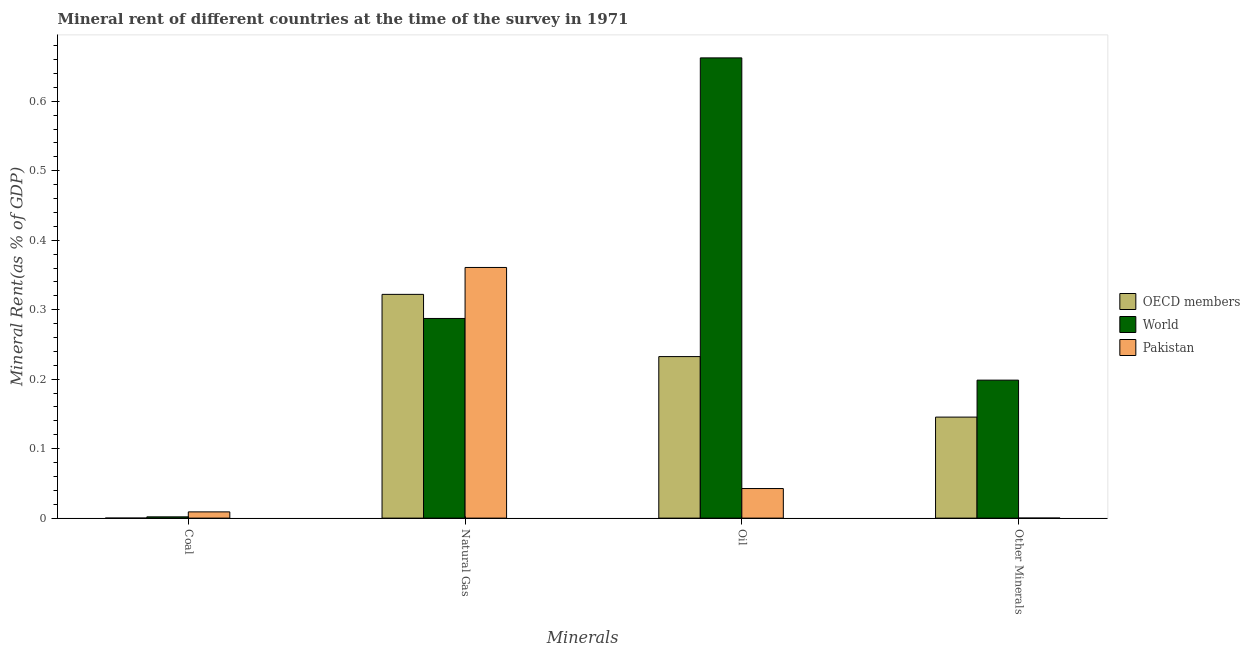How many different coloured bars are there?
Offer a terse response. 3. How many groups of bars are there?
Your response must be concise. 4. Are the number of bars on each tick of the X-axis equal?
Provide a short and direct response. Yes. How many bars are there on the 3rd tick from the left?
Make the answer very short. 3. How many bars are there on the 2nd tick from the right?
Offer a very short reply. 3. What is the label of the 4th group of bars from the left?
Make the answer very short. Other Minerals. What is the natural gas rent in OECD members?
Make the answer very short. 0.32. Across all countries, what is the maximum  rent of other minerals?
Your answer should be very brief. 0.2. Across all countries, what is the minimum  rent of other minerals?
Give a very brief answer. 2.58008287819044e-5. In which country was the oil rent maximum?
Make the answer very short. World. What is the total  rent of other minerals in the graph?
Your answer should be very brief. 0.34. What is the difference between the oil rent in World and that in Pakistan?
Your answer should be very brief. 0.62. What is the difference between the oil rent in World and the coal rent in OECD members?
Your response must be concise. 0.66. What is the average  rent of other minerals per country?
Offer a very short reply. 0.11. What is the difference between the coal rent and  rent of other minerals in World?
Your answer should be very brief. -0.2. In how many countries, is the oil rent greater than 0.32000000000000006 %?
Your answer should be very brief. 1. What is the ratio of the  rent of other minerals in World to that in OECD members?
Make the answer very short. 1.37. Is the natural gas rent in OECD members less than that in World?
Your response must be concise. No. Is the difference between the  rent of other minerals in World and Pakistan greater than the difference between the natural gas rent in World and Pakistan?
Give a very brief answer. Yes. What is the difference between the highest and the second highest  rent of other minerals?
Give a very brief answer. 0.05. What is the difference between the highest and the lowest coal rent?
Make the answer very short. 0.01. In how many countries, is the coal rent greater than the average coal rent taken over all countries?
Provide a succinct answer. 1. Is it the case that in every country, the sum of the oil rent and natural gas rent is greater than the sum of  rent of other minerals and coal rent?
Your answer should be compact. No. What does the 3rd bar from the right in Coal represents?
Your response must be concise. OECD members. Is it the case that in every country, the sum of the coal rent and natural gas rent is greater than the oil rent?
Offer a terse response. No. Are all the bars in the graph horizontal?
Keep it short and to the point. No. What is the difference between two consecutive major ticks on the Y-axis?
Your answer should be compact. 0.1. Does the graph contain grids?
Offer a very short reply. No. Where does the legend appear in the graph?
Provide a short and direct response. Center right. How many legend labels are there?
Keep it short and to the point. 3. What is the title of the graph?
Ensure brevity in your answer.  Mineral rent of different countries at the time of the survey in 1971. Does "Burkina Faso" appear as one of the legend labels in the graph?
Give a very brief answer. No. What is the label or title of the X-axis?
Keep it short and to the point. Minerals. What is the label or title of the Y-axis?
Offer a very short reply. Mineral Rent(as % of GDP). What is the Mineral Rent(as % of GDP) in OECD members in Coal?
Your response must be concise. 1.83188177110096e-6. What is the Mineral Rent(as % of GDP) of World in Coal?
Your answer should be very brief. 0. What is the Mineral Rent(as % of GDP) of Pakistan in Coal?
Ensure brevity in your answer.  0.01. What is the Mineral Rent(as % of GDP) of OECD members in Natural Gas?
Your answer should be compact. 0.32. What is the Mineral Rent(as % of GDP) of World in Natural Gas?
Provide a short and direct response. 0.29. What is the Mineral Rent(as % of GDP) in Pakistan in Natural Gas?
Offer a very short reply. 0.36. What is the Mineral Rent(as % of GDP) in OECD members in Oil?
Keep it short and to the point. 0.23. What is the Mineral Rent(as % of GDP) in World in Oil?
Offer a terse response. 0.66. What is the Mineral Rent(as % of GDP) in Pakistan in Oil?
Ensure brevity in your answer.  0.04. What is the Mineral Rent(as % of GDP) of OECD members in Other Minerals?
Make the answer very short. 0.15. What is the Mineral Rent(as % of GDP) of World in Other Minerals?
Your answer should be very brief. 0.2. What is the Mineral Rent(as % of GDP) of Pakistan in Other Minerals?
Your answer should be very brief. 2.58008287819044e-5. Across all Minerals, what is the maximum Mineral Rent(as % of GDP) in OECD members?
Offer a very short reply. 0.32. Across all Minerals, what is the maximum Mineral Rent(as % of GDP) of World?
Ensure brevity in your answer.  0.66. Across all Minerals, what is the maximum Mineral Rent(as % of GDP) of Pakistan?
Provide a short and direct response. 0.36. Across all Minerals, what is the minimum Mineral Rent(as % of GDP) of OECD members?
Offer a terse response. 1.83188177110096e-6. Across all Minerals, what is the minimum Mineral Rent(as % of GDP) of World?
Your response must be concise. 0. Across all Minerals, what is the minimum Mineral Rent(as % of GDP) of Pakistan?
Your answer should be very brief. 2.58008287819044e-5. What is the total Mineral Rent(as % of GDP) of OECD members in the graph?
Your response must be concise. 0.7. What is the total Mineral Rent(as % of GDP) in World in the graph?
Make the answer very short. 1.15. What is the total Mineral Rent(as % of GDP) in Pakistan in the graph?
Offer a very short reply. 0.41. What is the difference between the Mineral Rent(as % of GDP) of OECD members in Coal and that in Natural Gas?
Provide a short and direct response. -0.32. What is the difference between the Mineral Rent(as % of GDP) of World in Coal and that in Natural Gas?
Ensure brevity in your answer.  -0.29. What is the difference between the Mineral Rent(as % of GDP) of Pakistan in Coal and that in Natural Gas?
Provide a succinct answer. -0.35. What is the difference between the Mineral Rent(as % of GDP) in OECD members in Coal and that in Oil?
Your answer should be very brief. -0.23. What is the difference between the Mineral Rent(as % of GDP) of World in Coal and that in Oil?
Your response must be concise. -0.66. What is the difference between the Mineral Rent(as % of GDP) in Pakistan in Coal and that in Oil?
Offer a very short reply. -0.03. What is the difference between the Mineral Rent(as % of GDP) of OECD members in Coal and that in Other Minerals?
Provide a short and direct response. -0.15. What is the difference between the Mineral Rent(as % of GDP) in World in Coal and that in Other Minerals?
Provide a short and direct response. -0.2. What is the difference between the Mineral Rent(as % of GDP) in Pakistan in Coal and that in Other Minerals?
Ensure brevity in your answer.  0.01. What is the difference between the Mineral Rent(as % of GDP) of OECD members in Natural Gas and that in Oil?
Your answer should be compact. 0.09. What is the difference between the Mineral Rent(as % of GDP) in World in Natural Gas and that in Oil?
Ensure brevity in your answer.  -0.38. What is the difference between the Mineral Rent(as % of GDP) of Pakistan in Natural Gas and that in Oil?
Ensure brevity in your answer.  0.32. What is the difference between the Mineral Rent(as % of GDP) in OECD members in Natural Gas and that in Other Minerals?
Give a very brief answer. 0.18. What is the difference between the Mineral Rent(as % of GDP) in World in Natural Gas and that in Other Minerals?
Provide a short and direct response. 0.09. What is the difference between the Mineral Rent(as % of GDP) in Pakistan in Natural Gas and that in Other Minerals?
Make the answer very short. 0.36. What is the difference between the Mineral Rent(as % of GDP) of OECD members in Oil and that in Other Minerals?
Your answer should be compact. 0.09. What is the difference between the Mineral Rent(as % of GDP) of World in Oil and that in Other Minerals?
Your response must be concise. 0.46. What is the difference between the Mineral Rent(as % of GDP) in Pakistan in Oil and that in Other Minerals?
Offer a terse response. 0.04. What is the difference between the Mineral Rent(as % of GDP) in OECD members in Coal and the Mineral Rent(as % of GDP) in World in Natural Gas?
Provide a succinct answer. -0.29. What is the difference between the Mineral Rent(as % of GDP) in OECD members in Coal and the Mineral Rent(as % of GDP) in Pakistan in Natural Gas?
Offer a very short reply. -0.36. What is the difference between the Mineral Rent(as % of GDP) in World in Coal and the Mineral Rent(as % of GDP) in Pakistan in Natural Gas?
Provide a short and direct response. -0.36. What is the difference between the Mineral Rent(as % of GDP) in OECD members in Coal and the Mineral Rent(as % of GDP) in World in Oil?
Offer a very short reply. -0.66. What is the difference between the Mineral Rent(as % of GDP) in OECD members in Coal and the Mineral Rent(as % of GDP) in Pakistan in Oil?
Offer a terse response. -0.04. What is the difference between the Mineral Rent(as % of GDP) in World in Coal and the Mineral Rent(as % of GDP) in Pakistan in Oil?
Provide a succinct answer. -0.04. What is the difference between the Mineral Rent(as % of GDP) of OECD members in Coal and the Mineral Rent(as % of GDP) of World in Other Minerals?
Provide a short and direct response. -0.2. What is the difference between the Mineral Rent(as % of GDP) of World in Coal and the Mineral Rent(as % of GDP) of Pakistan in Other Minerals?
Give a very brief answer. 0. What is the difference between the Mineral Rent(as % of GDP) of OECD members in Natural Gas and the Mineral Rent(as % of GDP) of World in Oil?
Offer a terse response. -0.34. What is the difference between the Mineral Rent(as % of GDP) in OECD members in Natural Gas and the Mineral Rent(as % of GDP) in Pakistan in Oil?
Your answer should be very brief. 0.28. What is the difference between the Mineral Rent(as % of GDP) of World in Natural Gas and the Mineral Rent(as % of GDP) of Pakistan in Oil?
Keep it short and to the point. 0.24. What is the difference between the Mineral Rent(as % of GDP) in OECD members in Natural Gas and the Mineral Rent(as % of GDP) in World in Other Minerals?
Your response must be concise. 0.12. What is the difference between the Mineral Rent(as % of GDP) in OECD members in Natural Gas and the Mineral Rent(as % of GDP) in Pakistan in Other Minerals?
Keep it short and to the point. 0.32. What is the difference between the Mineral Rent(as % of GDP) in World in Natural Gas and the Mineral Rent(as % of GDP) in Pakistan in Other Minerals?
Provide a short and direct response. 0.29. What is the difference between the Mineral Rent(as % of GDP) of OECD members in Oil and the Mineral Rent(as % of GDP) of World in Other Minerals?
Keep it short and to the point. 0.03. What is the difference between the Mineral Rent(as % of GDP) in OECD members in Oil and the Mineral Rent(as % of GDP) in Pakistan in Other Minerals?
Provide a short and direct response. 0.23. What is the difference between the Mineral Rent(as % of GDP) of World in Oil and the Mineral Rent(as % of GDP) of Pakistan in Other Minerals?
Your answer should be compact. 0.66. What is the average Mineral Rent(as % of GDP) in OECD members per Minerals?
Provide a succinct answer. 0.17. What is the average Mineral Rent(as % of GDP) in World per Minerals?
Your response must be concise. 0.29. What is the average Mineral Rent(as % of GDP) of Pakistan per Minerals?
Offer a very short reply. 0.1. What is the difference between the Mineral Rent(as % of GDP) of OECD members and Mineral Rent(as % of GDP) of World in Coal?
Provide a succinct answer. -0. What is the difference between the Mineral Rent(as % of GDP) in OECD members and Mineral Rent(as % of GDP) in Pakistan in Coal?
Make the answer very short. -0.01. What is the difference between the Mineral Rent(as % of GDP) of World and Mineral Rent(as % of GDP) of Pakistan in Coal?
Ensure brevity in your answer.  -0.01. What is the difference between the Mineral Rent(as % of GDP) in OECD members and Mineral Rent(as % of GDP) in World in Natural Gas?
Give a very brief answer. 0.03. What is the difference between the Mineral Rent(as % of GDP) in OECD members and Mineral Rent(as % of GDP) in Pakistan in Natural Gas?
Provide a short and direct response. -0.04. What is the difference between the Mineral Rent(as % of GDP) of World and Mineral Rent(as % of GDP) of Pakistan in Natural Gas?
Your answer should be very brief. -0.07. What is the difference between the Mineral Rent(as % of GDP) of OECD members and Mineral Rent(as % of GDP) of World in Oil?
Your answer should be compact. -0.43. What is the difference between the Mineral Rent(as % of GDP) in OECD members and Mineral Rent(as % of GDP) in Pakistan in Oil?
Your response must be concise. 0.19. What is the difference between the Mineral Rent(as % of GDP) in World and Mineral Rent(as % of GDP) in Pakistan in Oil?
Make the answer very short. 0.62. What is the difference between the Mineral Rent(as % of GDP) in OECD members and Mineral Rent(as % of GDP) in World in Other Minerals?
Keep it short and to the point. -0.05. What is the difference between the Mineral Rent(as % of GDP) of OECD members and Mineral Rent(as % of GDP) of Pakistan in Other Minerals?
Offer a very short reply. 0.15. What is the difference between the Mineral Rent(as % of GDP) in World and Mineral Rent(as % of GDP) in Pakistan in Other Minerals?
Keep it short and to the point. 0.2. What is the ratio of the Mineral Rent(as % of GDP) of OECD members in Coal to that in Natural Gas?
Ensure brevity in your answer.  0. What is the ratio of the Mineral Rent(as % of GDP) in World in Coal to that in Natural Gas?
Make the answer very short. 0.01. What is the ratio of the Mineral Rent(as % of GDP) in Pakistan in Coal to that in Natural Gas?
Your response must be concise. 0.02. What is the ratio of the Mineral Rent(as % of GDP) of OECD members in Coal to that in Oil?
Offer a very short reply. 0. What is the ratio of the Mineral Rent(as % of GDP) of World in Coal to that in Oil?
Offer a very short reply. 0. What is the ratio of the Mineral Rent(as % of GDP) of Pakistan in Coal to that in Oil?
Your answer should be very brief. 0.21. What is the ratio of the Mineral Rent(as % of GDP) in OECD members in Coal to that in Other Minerals?
Keep it short and to the point. 0. What is the ratio of the Mineral Rent(as % of GDP) of World in Coal to that in Other Minerals?
Provide a short and direct response. 0.01. What is the ratio of the Mineral Rent(as % of GDP) in Pakistan in Coal to that in Other Minerals?
Your response must be concise. 347.46. What is the ratio of the Mineral Rent(as % of GDP) in OECD members in Natural Gas to that in Oil?
Keep it short and to the point. 1.39. What is the ratio of the Mineral Rent(as % of GDP) of World in Natural Gas to that in Oil?
Provide a short and direct response. 0.43. What is the ratio of the Mineral Rent(as % of GDP) of Pakistan in Natural Gas to that in Oil?
Your answer should be very brief. 8.47. What is the ratio of the Mineral Rent(as % of GDP) in OECD members in Natural Gas to that in Other Minerals?
Ensure brevity in your answer.  2.21. What is the ratio of the Mineral Rent(as % of GDP) in World in Natural Gas to that in Other Minerals?
Make the answer very short. 1.45. What is the ratio of the Mineral Rent(as % of GDP) of Pakistan in Natural Gas to that in Other Minerals?
Keep it short and to the point. 1.40e+04. What is the ratio of the Mineral Rent(as % of GDP) of OECD members in Oil to that in Other Minerals?
Your answer should be compact. 1.6. What is the ratio of the Mineral Rent(as % of GDP) in World in Oil to that in Other Minerals?
Ensure brevity in your answer.  3.34. What is the ratio of the Mineral Rent(as % of GDP) of Pakistan in Oil to that in Other Minerals?
Offer a terse response. 1650.45. What is the difference between the highest and the second highest Mineral Rent(as % of GDP) of OECD members?
Provide a short and direct response. 0.09. What is the difference between the highest and the second highest Mineral Rent(as % of GDP) of World?
Offer a terse response. 0.38. What is the difference between the highest and the second highest Mineral Rent(as % of GDP) of Pakistan?
Keep it short and to the point. 0.32. What is the difference between the highest and the lowest Mineral Rent(as % of GDP) in OECD members?
Offer a terse response. 0.32. What is the difference between the highest and the lowest Mineral Rent(as % of GDP) in World?
Keep it short and to the point. 0.66. What is the difference between the highest and the lowest Mineral Rent(as % of GDP) in Pakistan?
Provide a succinct answer. 0.36. 